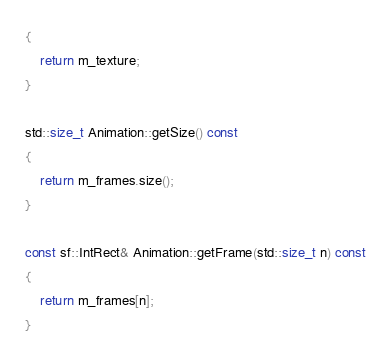Convert code to text. <code><loc_0><loc_0><loc_500><loc_500><_C++_>{
    return m_texture;
}

std::size_t Animation::getSize() const
{
    return m_frames.size();
}

const sf::IntRect& Animation::getFrame(std::size_t n) const
{
    return m_frames[n];
}
</code> 